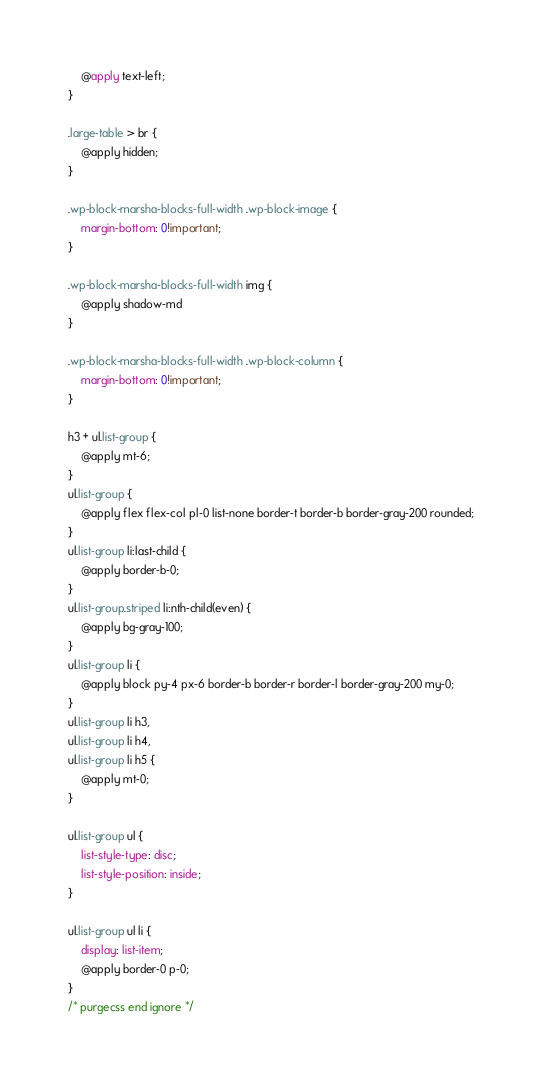<code> <loc_0><loc_0><loc_500><loc_500><_CSS_>    @apply text-left;
}

.large-table > br {
    @apply hidden;
}

.wp-block-marsha-blocks-full-width .wp-block-image {
    margin-bottom: 0!important;
}

.wp-block-marsha-blocks-full-width img {
    @apply shadow-md
}

.wp-block-marsha-blocks-full-width .wp-block-column {
    margin-bottom: 0!important;
}

h3 + ul.list-group {
    @apply mt-6;
}
ul.list-group {
    @apply flex flex-col pl-0 list-none border-t border-b border-gray-200 rounded;
}
ul.list-group li:last-child {
    @apply border-b-0;
}
ul.list-group.striped li:nth-child(even) {
    @apply bg-gray-100;
}
ul.list-group li {
    @apply block py-4 px-6 border-b border-r border-l border-gray-200 my-0;
}
ul.list-group li h3,
ul.list-group li h4,
ul.list-group li h5 {
    @apply mt-0;
}

ul.list-group ul {
    list-style-type: disc;
    list-style-position: inside;
}

ul.list-group ul li {
    display: list-item;
    @apply border-0 p-0;
}
/* purgecss end ignore */</code> 